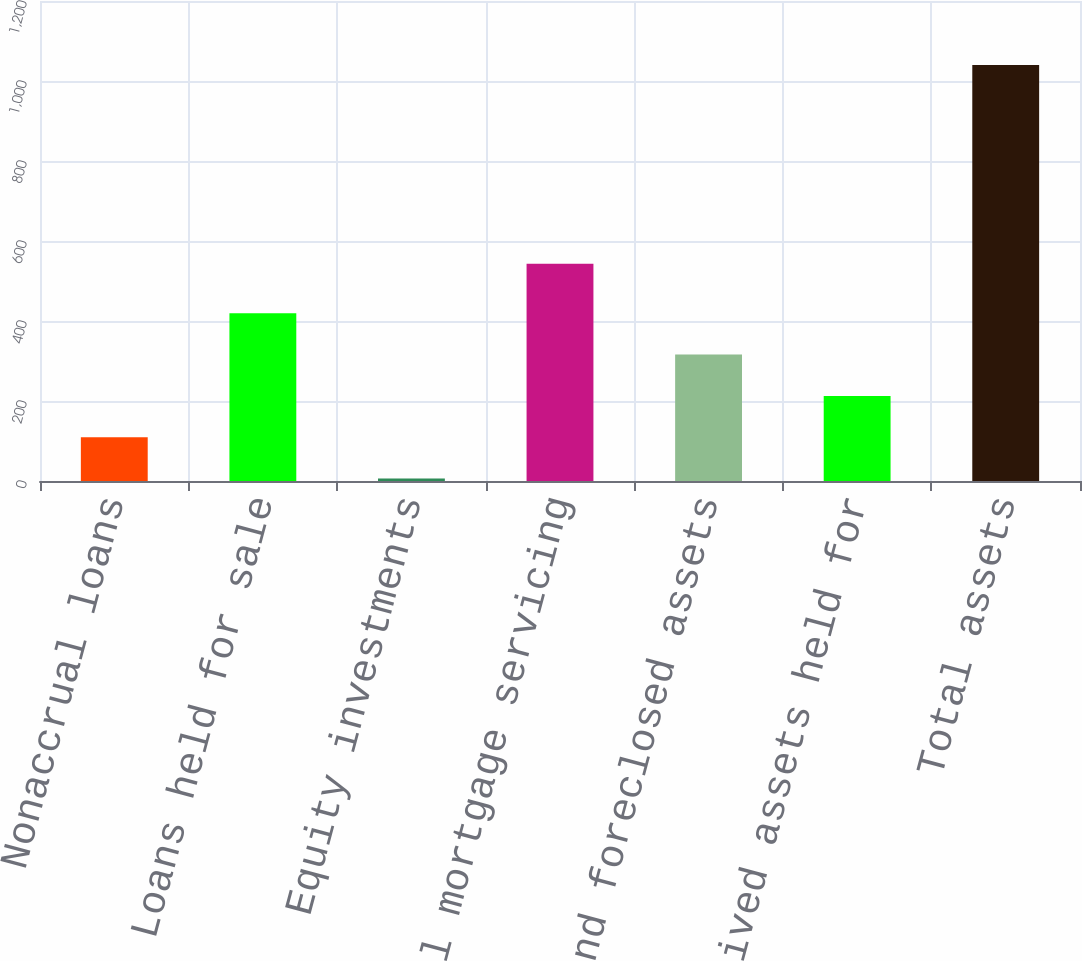<chart> <loc_0><loc_0><loc_500><loc_500><bar_chart><fcel>Nonaccrual loans<fcel>Loans held for sale<fcel>Equity investments<fcel>Commercial mortgage servicing<fcel>OREO and foreclosed assets<fcel>Long-lived assets held for<fcel>Total assets<nl><fcel>109.4<fcel>419.6<fcel>6<fcel>543<fcel>316.2<fcel>212.8<fcel>1040<nl></chart> 